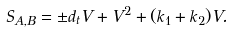Convert formula to latex. <formula><loc_0><loc_0><loc_500><loc_500>S _ { A , B } = \pm d _ { t } V + V ^ { 2 } + ( k _ { 1 } + k _ { 2 } ) V .</formula> 